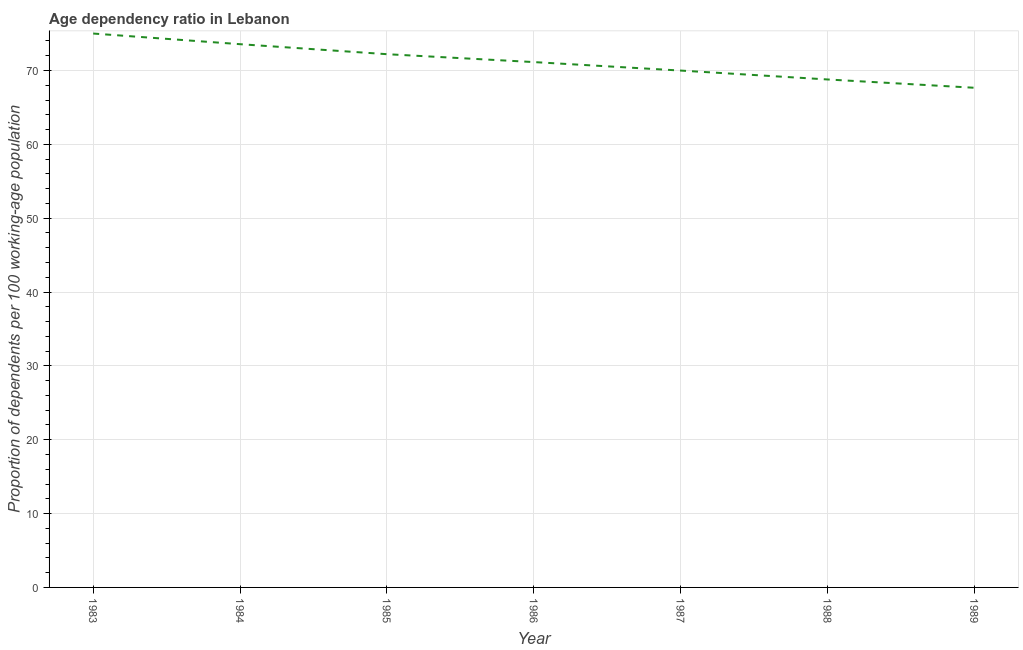What is the age dependency ratio in 1989?
Your answer should be compact. 67.66. Across all years, what is the maximum age dependency ratio?
Your response must be concise. 75. Across all years, what is the minimum age dependency ratio?
Your answer should be compact. 67.66. What is the sum of the age dependency ratio?
Your answer should be compact. 498.34. What is the difference between the age dependency ratio in 1987 and 1989?
Provide a succinct answer. 2.33. What is the average age dependency ratio per year?
Give a very brief answer. 71.19. What is the median age dependency ratio?
Offer a terse response. 71.14. In how many years, is the age dependency ratio greater than 40 ?
Ensure brevity in your answer.  7. Do a majority of the years between 1987 and 1983 (inclusive) have age dependency ratio greater than 24 ?
Keep it short and to the point. Yes. What is the ratio of the age dependency ratio in 1984 to that in 1989?
Your answer should be compact. 1.09. Is the age dependency ratio in 1987 less than that in 1988?
Your answer should be compact. No. What is the difference between the highest and the second highest age dependency ratio?
Make the answer very short. 1.44. What is the difference between the highest and the lowest age dependency ratio?
Ensure brevity in your answer.  7.34. Does the age dependency ratio monotonically increase over the years?
Provide a short and direct response. No. How many years are there in the graph?
Offer a terse response. 7. Does the graph contain any zero values?
Your answer should be compact. No. What is the title of the graph?
Your answer should be very brief. Age dependency ratio in Lebanon. What is the label or title of the Y-axis?
Your answer should be compact. Proportion of dependents per 100 working-age population. What is the Proportion of dependents per 100 working-age population of 1983?
Offer a very short reply. 75. What is the Proportion of dependents per 100 working-age population in 1984?
Your answer should be very brief. 73.56. What is the Proportion of dependents per 100 working-age population in 1985?
Your answer should be compact. 72.21. What is the Proportion of dependents per 100 working-age population in 1986?
Provide a succinct answer. 71.14. What is the Proportion of dependents per 100 working-age population of 1987?
Your response must be concise. 69.99. What is the Proportion of dependents per 100 working-age population of 1988?
Give a very brief answer. 68.78. What is the Proportion of dependents per 100 working-age population in 1989?
Ensure brevity in your answer.  67.66. What is the difference between the Proportion of dependents per 100 working-age population in 1983 and 1984?
Provide a short and direct response. 1.44. What is the difference between the Proportion of dependents per 100 working-age population in 1983 and 1985?
Your answer should be very brief. 2.8. What is the difference between the Proportion of dependents per 100 working-age population in 1983 and 1986?
Make the answer very short. 3.86. What is the difference between the Proportion of dependents per 100 working-age population in 1983 and 1987?
Your response must be concise. 5.01. What is the difference between the Proportion of dependents per 100 working-age population in 1983 and 1988?
Give a very brief answer. 6.22. What is the difference between the Proportion of dependents per 100 working-age population in 1983 and 1989?
Offer a terse response. 7.34. What is the difference between the Proportion of dependents per 100 working-age population in 1984 and 1985?
Give a very brief answer. 1.35. What is the difference between the Proportion of dependents per 100 working-age population in 1984 and 1986?
Offer a very short reply. 2.42. What is the difference between the Proportion of dependents per 100 working-age population in 1984 and 1987?
Make the answer very short. 3.57. What is the difference between the Proportion of dependents per 100 working-age population in 1984 and 1988?
Give a very brief answer. 4.78. What is the difference between the Proportion of dependents per 100 working-age population in 1984 and 1989?
Offer a terse response. 5.9. What is the difference between the Proportion of dependents per 100 working-age population in 1985 and 1986?
Offer a very short reply. 1.07. What is the difference between the Proportion of dependents per 100 working-age population in 1985 and 1987?
Keep it short and to the point. 2.22. What is the difference between the Proportion of dependents per 100 working-age population in 1985 and 1988?
Your response must be concise. 3.42. What is the difference between the Proportion of dependents per 100 working-age population in 1985 and 1989?
Offer a terse response. 4.55. What is the difference between the Proportion of dependents per 100 working-age population in 1986 and 1987?
Ensure brevity in your answer.  1.15. What is the difference between the Proportion of dependents per 100 working-age population in 1986 and 1988?
Offer a very short reply. 2.35. What is the difference between the Proportion of dependents per 100 working-age population in 1986 and 1989?
Your answer should be compact. 3.48. What is the difference between the Proportion of dependents per 100 working-age population in 1987 and 1988?
Your answer should be compact. 1.2. What is the difference between the Proportion of dependents per 100 working-age population in 1987 and 1989?
Offer a terse response. 2.33. What is the difference between the Proportion of dependents per 100 working-age population in 1988 and 1989?
Make the answer very short. 1.12. What is the ratio of the Proportion of dependents per 100 working-age population in 1983 to that in 1985?
Give a very brief answer. 1.04. What is the ratio of the Proportion of dependents per 100 working-age population in 1983 to that in 1986?
Your response must be concise. 1.05. What is the ratio of the Proportion of dependents per 100 working-age population in 1983 to that in 1987?
Keep it short and to the point. 1.07. What is the ratio of the Proportion of dependents per 100 working-age population in 1983 to that in 1988?
Your answer should be very brief. 1.09. What is the ratio of the Proportion of dependents per 100 working-age population in 1983 to that in 1989?
Provide a succinct answer. 1.11. What is the ratio of the Proportion of dependents per 100 working-age population in 1984 to that in 1985?
Your response must be concise. 1.02. What is the ratio of the Proportion of dependents per 100 working-age population in 1984 to that in 1986?
Give a very brief answer. 1.03. What is the ratio of the Proportion of dependents per 100 working-age population in 1984 to that in 1987?
Keep it short and to the point. 1.05. What is the ratio of the Proportion of dependents per 100 working-age population in 1984 to that in 1988?
Offer a very short reply. 1.07. What is the ratio of the Proportion of dependents per 100 working-age population in 1984 to that in 1989?
Offer a terse response. 1.09. What is the ratio of the Proportion of dependents per 100 working-age population in 1985 to that in 1986?
Ensure brevity in your answer.  1.01. What is the ratio of the Proportion of dependents per 100 working-age population in 1985 to that in 1987?
Your answer should be compact. 1.03. What is the ratio of the Proportion of dependents per 100 working-age population in 1985 to that in 1988?
Make the answer very short. 1.05. What is the ratio of the Proportion of dependents per 100 working-age population in 1985 to that in 1989?
Provide a succinct answer. 1.07. What is the ratio of the Proportion of dependents per 100 working-age population in 1986 to that in 1988?
Offer a very short reply. 1.03. What is the ratio of the Proportion of dependents per 100 working-age population in 1986 to that in 1989?
Your answer should be compact. 1.05. What is the ratio of the Proportion of dependents per 100 working-age population in 1987 to that in 1988?
Your answer should be compact. 1.02. What is the ratio of the Proportion of dependents per 100 working-age population in 1987 to that in 1989?
Your response must be concise. 1.03. 